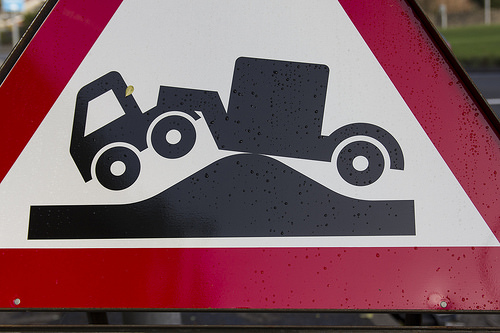<image>
Is there a sign next to the truck? No. The sign is not positioned next to the truck. They are located in different areas of the scene. Is the car in front of the sign? No. The car is not in front of the sign. The spatial positioning shows a different relationship between these objects. 